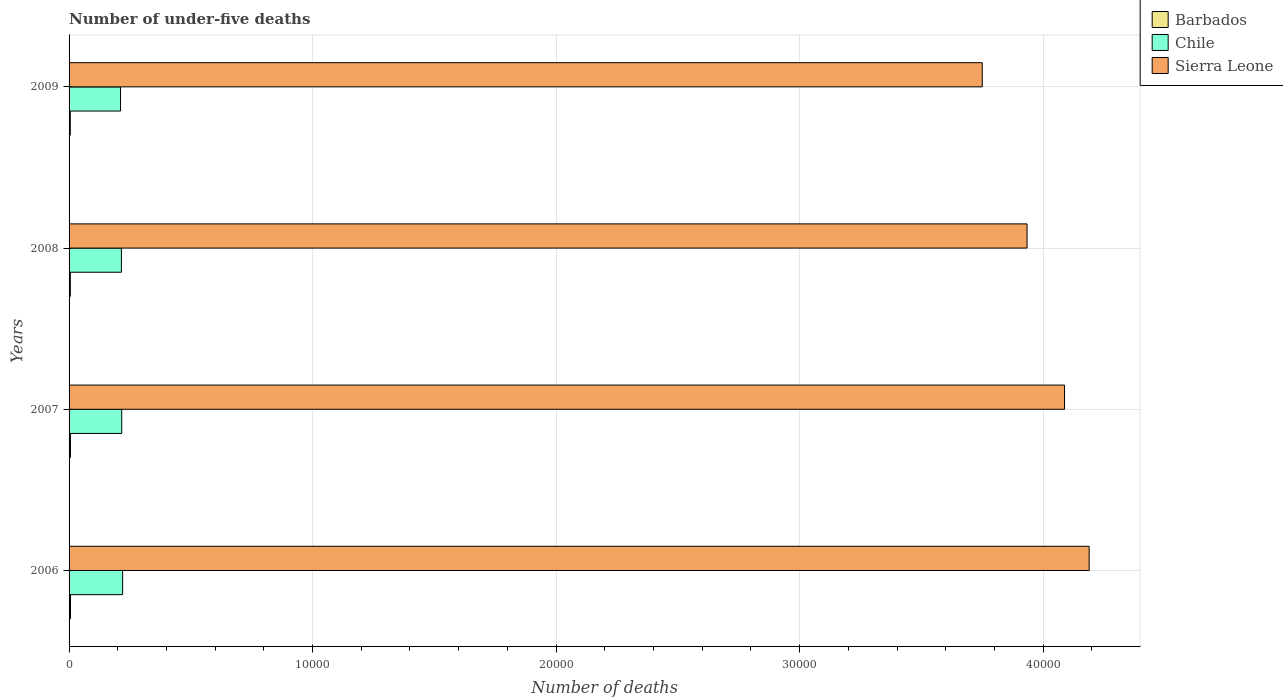How many different coloured bars are there?
Your answer should be very brief. 3. How many groups of bars are there?
Provide a succinct answer. 4. Are the number of bars on each tick of the Y-axis equal?
Provide a short and direct response. Yes. How many bars are there on the 4th tick from the top?
Offer a very short reply. 3. In how many cases, is the number of bars for a given year not equal to the number of legend labels?
Your response must be concise. 0. What is the number of under-five deaths in Sierra Leone in 2009?
Keep it short and to the point. 3.75e+04. Across all years, what is the maximum number of under-five deaths in Chile?
Keep it short and to the point. 2200. Across all years, what is the minimum number of under-five deaths in Chile?
Your response must be concise. 2114. In which year was the number of under-five deaths in Barbados minimum?
Your response must be concise. 2009. What is the total number of under-five deaths in Chile in the graph?
Keep it short and to the point. 8626. What is the difference between the number of under-five deaths in Chile in 2006 and that in 2009?
Keep it short and to the point. 86. What is the difference between the number of under-five deaths in Barbados in 2009 and the number of under-five deaths in Chile in 2007?
Your answer should be compact. -2111. What is the average number of under-five deaths in Chile per year?
Make the answer very short. 2156.5. In the year 2006, what is the difference between the number of under-five deaths in Chile and number of under-five deaths in Barbados?
Give a very brief answer. 2141. What is the ratio of the number of under-five deaths in Barbados in 2006 to that in 2009?
Keep it short and to the point. 1.16. What is the difference between the highest and the lowest number of under-five deaths in Chile?
Provide a short and direct response. 86. Is the sum of the number of under-five deaths in Sierra Leone in 2007 and 2009 greater than the maximum number of under-five deaths in Chile across all years?
Provide a short and direct response. Yes. Is it the case that in every year, the sum of the number of under-five deaths in Chile and number of under-five deaths in Barbados is greater than the number of under-five deaths in Sierra Leone?
Provide a short and direct response. No. Are the values on the major ticks of X-axis written in scientific E-notation?
Provide a short and direct response. No. Does the graph contain grids?
Ensure brevity in your answer.  Yes. Where does the legend appear in the graph?
Your answer should be compact. Top right. How many legend labels are there?
Make the answer very short. 3. How are the legend labels stacked?
Ensure brevity in your answer.  Vertical. What is the title of the graph?
Offer a terse response. Number of under-five deaths. What is the label or title of the X-axis?
Ensure brevity in your answer.  Number of deaths. What is the Number of deaths in Barbados in 2006?
Keep it short and to the point. 59. What is the Number of deaths in Chile in 2006?
Your response must be concise. 2200. What is the Number of deaths of Sierra Leone in 2006?
Offer a terse response. 4.19e+04. What is the Number of deaths in Barbados in 2007?
Give a very brief answer. 56. What is the Number of deaths of Chile in 2007?
Give a very brief answer. 2162. What is the Number of deaths of Sierra Leone in 2007?
Your response must be concise. 4.09e+04. What is the Number of deaths of Barbados in 2008?
Give a very brief answer. 53. What is the Number of deaths of Chile in 2008?
Make the answer very short. 2150. What is the Number of deaths of Sierra Leone in 2008?
Your answer should be very brief. 3.93e+04. What is the Number of deaths of Barbados in 2009?
Your answer should be compact. 51. What is the Number of deaths in Chile in 2009?
Your response must be concise. 2114. What is the Number of deaths in Sierra Leone in 2009?
Your answer should be very brief. 3.75e+04. Across all years, what is the maximum Number of deaths in Chile?
Your answer should be compact. 2200. Across all years, what is the maximum Number of deaths in Sierra Leone?
Your answer should be compact. 4.19e+04. Across all years, what is the minimum Number of deaths of Barbados?
Your answer should be very brief. 51. Across all years, what is the minimum Number of deaths in Chile?
Make the answer very short. 2114. Across all years, what is the minimum Number of deaths of Sierra Leone?
Give a very brief answer. 3.75e+04. What is the total Number of deaths of Barbados in the graph?
Keep it short and to the point. 219. What is the total Number of deaths in Chile in the graph?
Ensure brevity in your answer.  8626. What is the total Number of deaths in Sierra Leone in the graph?
Keep it short and to the point. 1.60e+05. What is the difference between the Number of deaths in Barbados in 2006 and that in 2007?
Offer a terse response. 3. What is the difference between the Number of deaths in Chile in 2006 and that in 2007?
Offer a terse response. 38. What is the difference between the Number of deaths of Sierra Leone in 2006 and that in 2007?
Keep it short and to the point. 1011. What is the difference between the Number of deaths of Chile in 2006 and that in 2008?
Make the answer very short. 50. What is the difference between the Number of deaths in Sierra Leone in 2006 and that in 2008?
Give a very brief answer. 2551. What is the difference between the Number of deaths in Chile in 2006 and that in 2009?
Make the answer very short. 86. What is the difference between the Number of deaths of Sierra Leone in 2006 and that in 2009?
Your response must be concise. 4391. What is the difference between the Number of deaths of Sierra Leone in 2007 and that in 2008?
Keep it short and to the point. 1540. What is the difference between the Number of deaths in Chile in 2007 and that in 2009?
Your answer should be very brief. 48. What is the difference between the Number of deaths of Sierra Leone in 2007 and that in 2009?
Your answer should be very brief. 3380. What is the difference between the Number of deaths of Sierra Leone in 2008 and that in 2009?
Ensure brevity in your answer.  1840. What is the difference between the Number of deaths in Barbados in 2006 and the Number of deaths in Chile in 2007?
Offer a very short reply. -2103. What is the difference between the Number of deaths of Barbados in 2006 and the Number of deaths of Sierra Leone in 2007?
Give a very brief answer. -4.08e+04. What is the difference between the Number of deaths in Chile in 2006 and the Number of deaths in Sierra Leone in 2007?
Offer a terse response. -3.87e+04. What is the difference between the Number of deaths in Barbados in 2006 and the Number of deaths in Chile in 2008?
Keep it short and to the point. -2091. What is the difference between the Number of deaths in Barbados in 2006 and the Number of deaths in Sierra Leone in 2008?
Your response must be concise. -3.93e+04. What is the difference between the Number of deaths of Chile in 2006 and the Number of deaths of Sierra Leone in 2008?
Your response must be concise. -3.71e+04. What is the difference between the Number of deaths of Barbados in 2006 and the Number of deaths of Chile in 2009?
Make the answer very short. -2055. What is the difference between the Number of deaths in Barbados in 2006 and the Number of deaths in Sierra Leone in 2009?
Your response must be concise. -3.74e+04. What is the difference between the Number of deaths in Chile in 2006 and the Number of deaths in Sierra Leone in 2009?
Your answer should be compact. -3.53e+04. What is the difference between the Number of deaths of Barbados in 2007 and the Number of deaths of Chile in 2008?
Keep it short and to the point. -2094. What is the difference between the Number of deaths of Barbados in 2007 and the Number of deaths of Sierra Leone in 2008?
Make the answer very short. -3.93e+04. What is the difference between the Number of deaths of Chile in 2007 and the Number of deaths of Sierra Leone in 2008?
Keep it short and to the point. -3.72e+04. What is the difference between the Number of deaths in Barbados in 2007 and the Number of deaths in Chile in 2009?
Your answer should be compact. -2058. What is the difference between the Number of deaths in Barbados in 2007 and the Number of deaths in Sierra Leone in 2009?
Your answer should be compact. -3.74e+04. What is the difference between the Number of deaths in Chile in 2007 and the Number of deaths in Sierra Leone in 2009?
Provide a short and direct response. -3.53e+04. What is the difference between the Number of deaths in Barbados in 2008 and the Number of deaths in Chile in 2009?
Provide a short and direct response. -2061. What is the difference between the Number of deaths in Barbados in 2008 and the Number of deaths in Sierra Leone in 2009?
Offer a very short reply. -3.74e+04. What is the difference between the Number of deaths in Chile in 2008 and the Number of deaths in Sierra Leone in 2009?
Provide a short and direct response. -3.54e+04. What is the average Number of deaths in Barbados per year?
Ensure brevity in your answer.  54.75. What is the average Number of deaths in Chile per year?
Your response must be concise. 2156.5. What is the average Number of deaths in Sierra Leone per year?
Offer a terse response. 3.99e+04. In the year 2006, what is the difference between the Number of deaths of Barbados and Number of deaths of Chile?
Keep it short and to the point. -2141. In the year 2006, what is the difference between the Number of deaths of Barbados and Number of deaths of Sierra Leone?
Your answer should be very brief. -4.18e+04. In the year 2006, what is the difference between the Number of deaths of Chile and Number of deaths of Sierra Leone?
Give a very brief answer. -3.97e+04. In the year 2007, what is the difference between the Number of deaths in Barbados and Number of deaths in Chile?
Give a very brief answer. -2106. In the year 2007, what is the difference between the Number of deaths in Barbados and Number of deaths in Sierra Leone?
Your answer should be compact. -4.08e+04. In the year 2007, what is the difference between the Number of deaths of Chile and Number of deaths of Sierra Leone?
Make the answer very short. -3.87e+04. In the year 2008, what is the difference between the Number of deaths in Barbados and Number of deaths in Chile?
Your answer should be compact. -2097. In the year 2008, what is the difference between the Number of deaths of Barbados and Number of deaths of Sierra Leone?
Offer a very short reply. -3.93e+04. In the year 2008, what is the difference between the Number of deaths in Chile and Number of deaths in Sierra Leone?
Offer a very short reply. -3.72e+04. In the year 2009, what is the difference between the Number of deaths of Barbados and Number of deaths of Chile?
Provide a short and direct response. -2063. In the year 2009, what is the difference between the Number of deaths in Barbados and Number of deaths in Sierra Leone?
Offer a very short reply. -3.74e+04. In the year 2009, what is the difference between the Number of deaths of Chile and Number of deaths of Sierra Leone?
Make the answer very short. -3.54e+04. What is the ratio of the Number of deaths of Barbados in 2006 to that in 2007?
Make the answer very short. 1.05. What is the ratio of the Number of deaths of Chile in 2006 to that in 2007?
Provide a succinct answer. 1.02. What is the ratio of the Number of deaths of Sierra Leone in 2006 to that in 2007?
Your answer should be compact. 1.02. What is the ratio of the Number of deaths of Barbados in 2006 to that in 2008?
Offer a very short reply. 1.11. What is the ratio of the Number of deaths of Chile in 2006 to that in 2008?
Make the answer very short. 1.02. What is the ratio of the Number of deaths of Sierra Leone in 2006 to that in 2008?
Give a very brief answer. 1.06. What is the ratio of the Number of deaths of Barbados in 2006 to that in 2009?
Offer a terse response. 1.16. What is the ratio of the Number of deaths in Chile in 2006 to that in 2009?
Provide a succinct answer. 1.04. What is the ratio of the Number of deaths in Sierra Leone in 2006 to that in 2009?
Keep it short and to the point. 1.12. What is the ratio of the Number of deaths in Barbados in 2007 to that in 2008?
Your answer should be compact. 1.06. What is the ratio of the Number of deaths in Chile in 2007 to that in 2008?
Offer a very short reply. 1.01. What is the ratio of the Number of deaths in Sierra Leone in 2007 to that in 2008?
Offer a terse response. 1.04. What is the ratio of the Number of deaths of Barbados in 2007 to that in 2009?
Give a very brief answer. 1.1. What is the ratio of the Number of deaths of Chile in 2007 to that in 2009?
Offer a terse response. 1.02. What is the ratio of the Number of deaths of Sierra Leone in 2007 to that in 2009?
Keep it short and to the point. 1.09. What is the ratio of the Number of deaths of Barbados in 2008 to that in 2009?
Make the answer very short. 1.04. What is the ratio of the Number of deaths of Chile in 2008 to that in 2009?
Offer a very short reply. 1.02. What is the ratio of the Number of deaths of Sierra Leone in 2008 to that in 2009?
Your response must be concise. 1.05. What is the difference between the highest and the second highest Number of deaths in Barbados?
Give a very brief answer. 3. What is the difference between the highest and the second highest Number of deaths of Sierra Leone?
Your answer should be very brief. 1011. What is the difference between the highest and the lowest Number of deaths of Chile?
Offer a very short reply. 86. What is the difference between the highest and the lowest Number of deaths in Sierra Leone?
Your answer should be compact. 4391. 